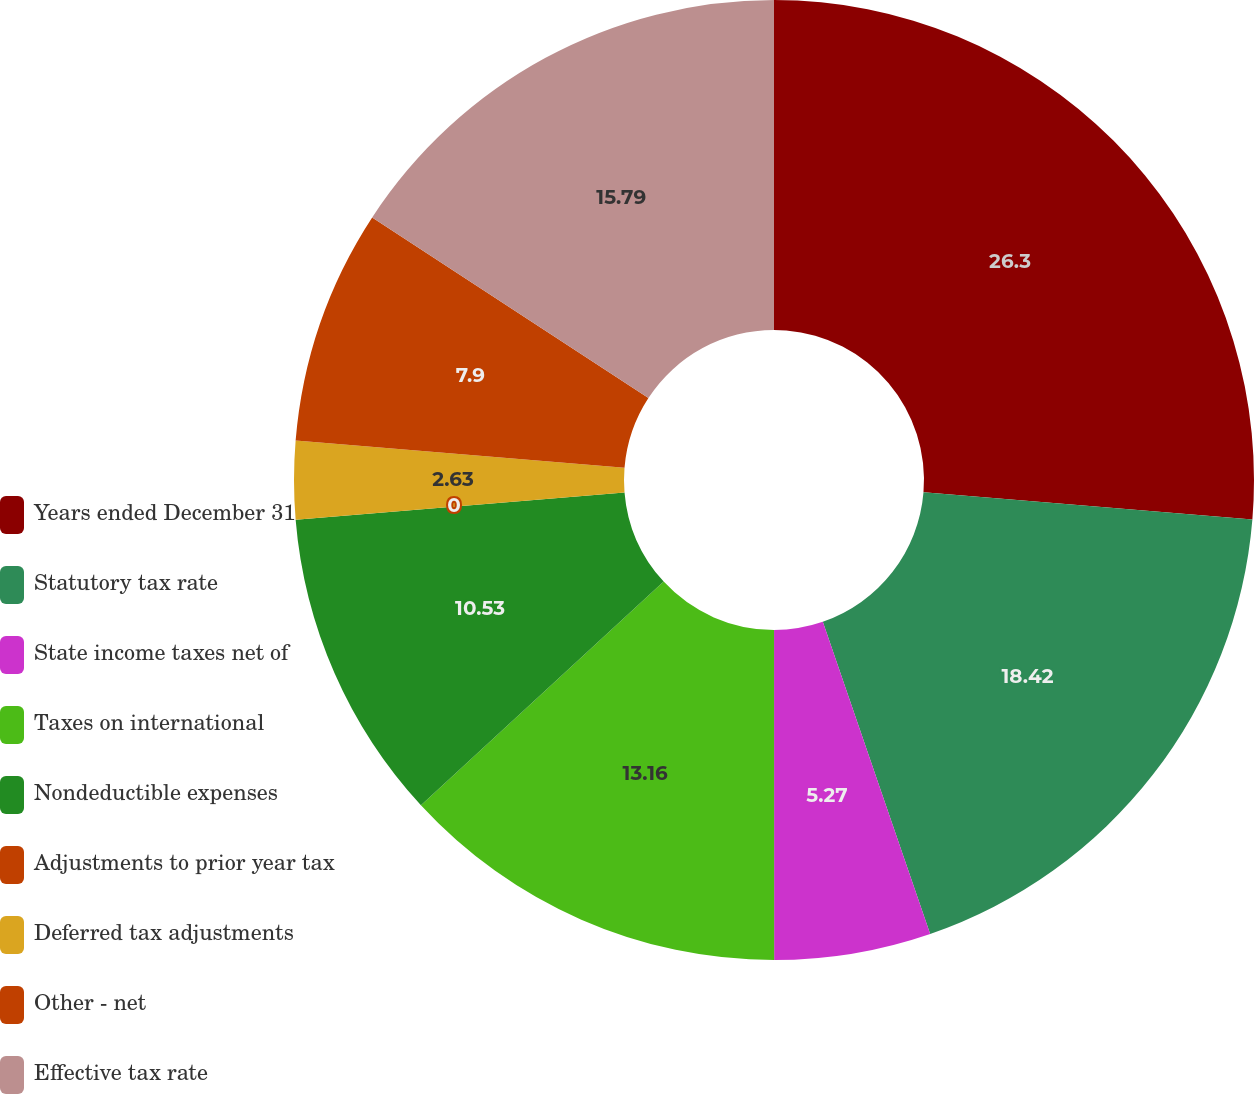<chart> <loc_0><loc_0><loc_500><loc_500><pie_chart><fcel>Years ended December 31<fcel>Statutory tax rate<fcel>State income taxes net of<fcel>Taxes on international<fcel>Nondeductible expenses<fcel>Adjustments to prior year tax<fcel>Deferred tax adjustments<fcel>Other - net<fcel>Effective tax rate<nl><fcel>26.31%<fcel>18.42%<fcel>5.27%<fcel>13.16%<fcel>10.53%<fcel>0.0%<fcel>2.63%<fcel>7.9%<fcel>15.79%<nl></chart> 